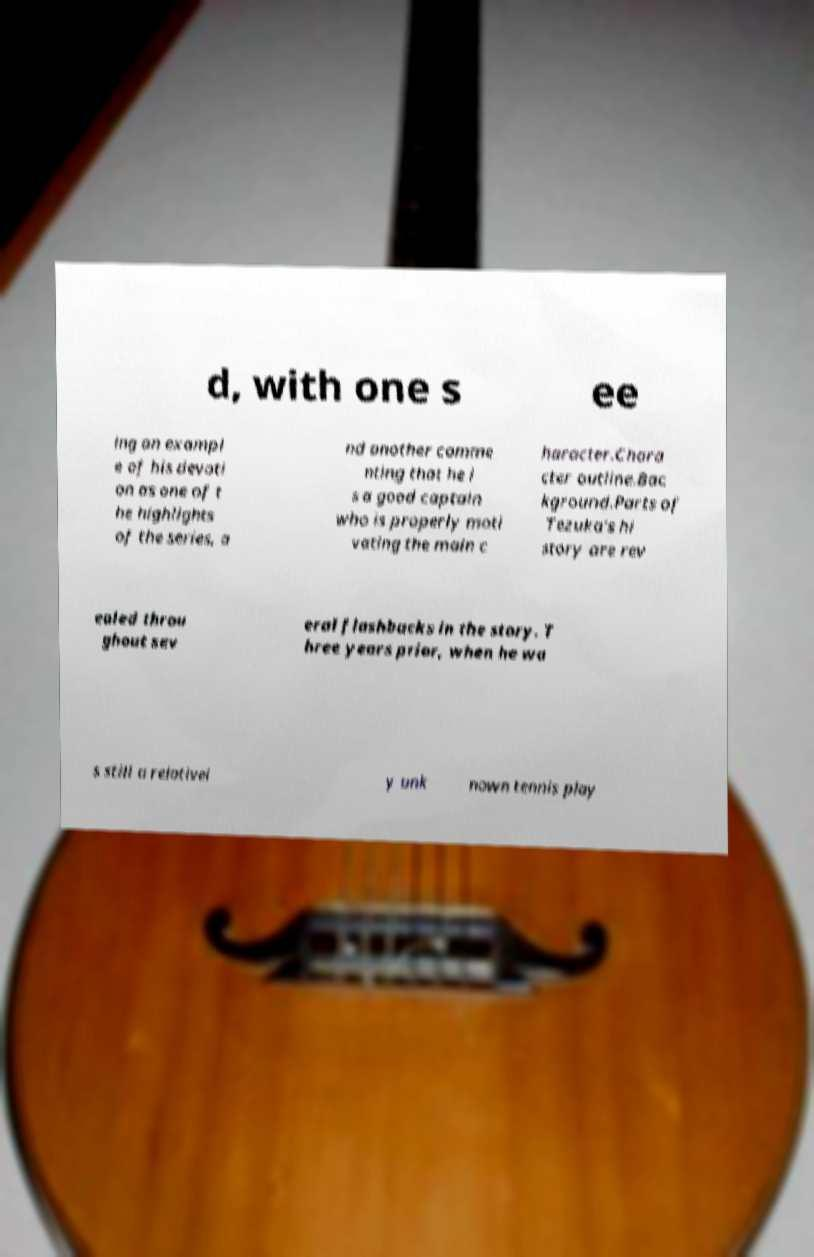Could you extract and type out the text from this image? d, with one s ee ing an exampl e of his devoti on as one of t he highlights of the series, a nd another comme nting that he i s a good captain who is properly moti vating the main c haracter.Chara cter outline.Bac kground.Parts of Tezuka's hi story are rev ealed throu ghout sev eral flashbacks in the story. T hree years prior, when he wa s still a relativel y unk nown tennis play 